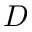<formula> <loc_0><loc_0><loc_500><loc_500>D</formula> 